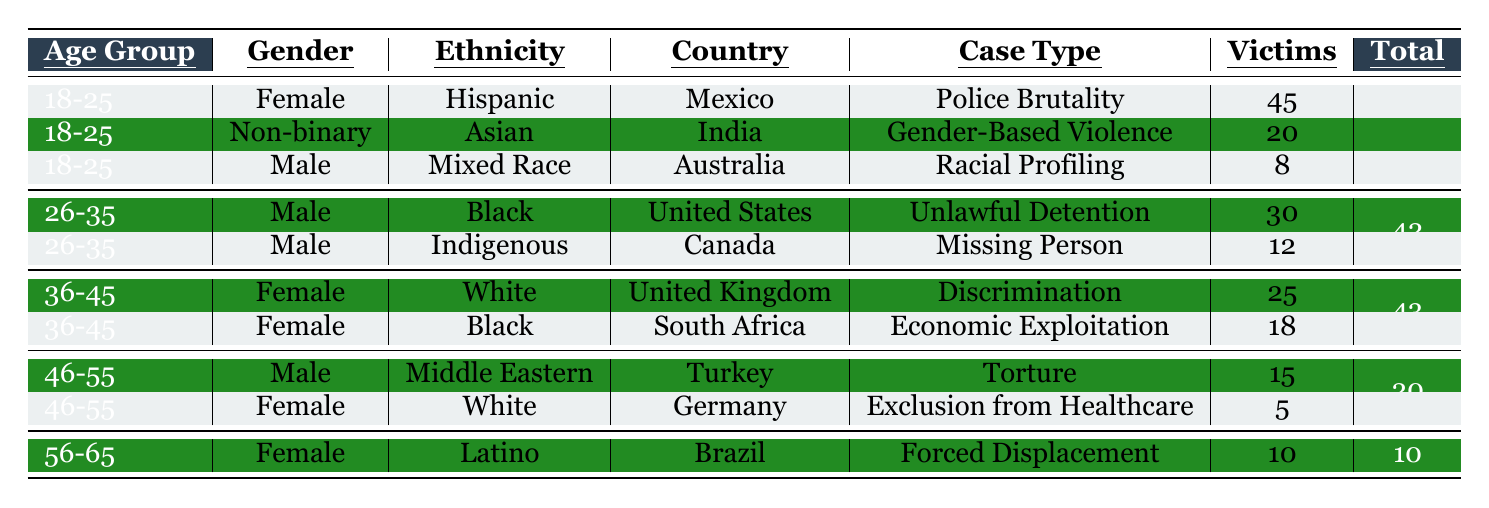What is the number of victims in the "Police Brutality" case type? To find this, look for the row labeled "Police Brutality" in the case type column. The corresponding number of victims in that row is 45.
Answer: 45 Which age group has the highest number of victims? Reviewing the table, the 18-25 age group has a total of 73 victims when you sum the victims from all cases within that age group: 45 (Police Brutality) + 20 (Gender-Based Violence) + 8 (Racial Profiling). This is the highest among all age groups.
Answer: 18-25 How many victims are female in the 36-45 age group? For the 36-45 age group, there are two victims listed as female in the table. Adding these numbers gives: 25 (Discrimination) + 18 (Economic Exploitation) = 43.
Answer: 43 What case type has the least number of victims? In the table, the lowest number of victims is found under the "Exclusion from Healthcare" case type with only 5 victims. This is clearly indicated in its corresponding row.
Answer: Exclusion from Healthcare Is there any case type listed for victims aged 56-65? Yes, there is a case type listed for the 56-65 age group; the case type is "Forced Displacement," which corresponds to 10 victims.
Answer: Yes What is the total number of victims across all age groups? To find the total, we need to add together all the victims from each of the case types. This gives us: 45 + 30 + 25 + 15 + 20 + 18 + 12 + 10 + 8 + 5 = 278.
Answer: 278 How many victims are Black across all age groups? We identify the rows corresponding to Black individuals: 18-25 (18 victims) and 36-45 (18 victims), totaling 36 victims overall.
Answer: 36 Is there a case type associated with males above the age of 55? No, according to the table, there are no male victims listed in the age bracket above 55. The only victim in that age group is a female.
Answer: No What percentage of the total victims belong to the age group 26-35? The total number of victims in the 26-35 age group is 42, and the overall total is 278. To find the percentage, calculate (42 / 278) * 100 = 15.1%.
Answer: 15.1% How does the number of victims in "Economic Exploitation" compare to "Unlawful Detention"? "Economic Exploitation" has 18 victims, while "Unlawful Detention" has 30 victims. Comparing these, 30 is greater than 18, showing that less victims suffered from Economic Exploitation than those subjected to Unlawful Detention.
Answer: Unlawful Detention has more victims 